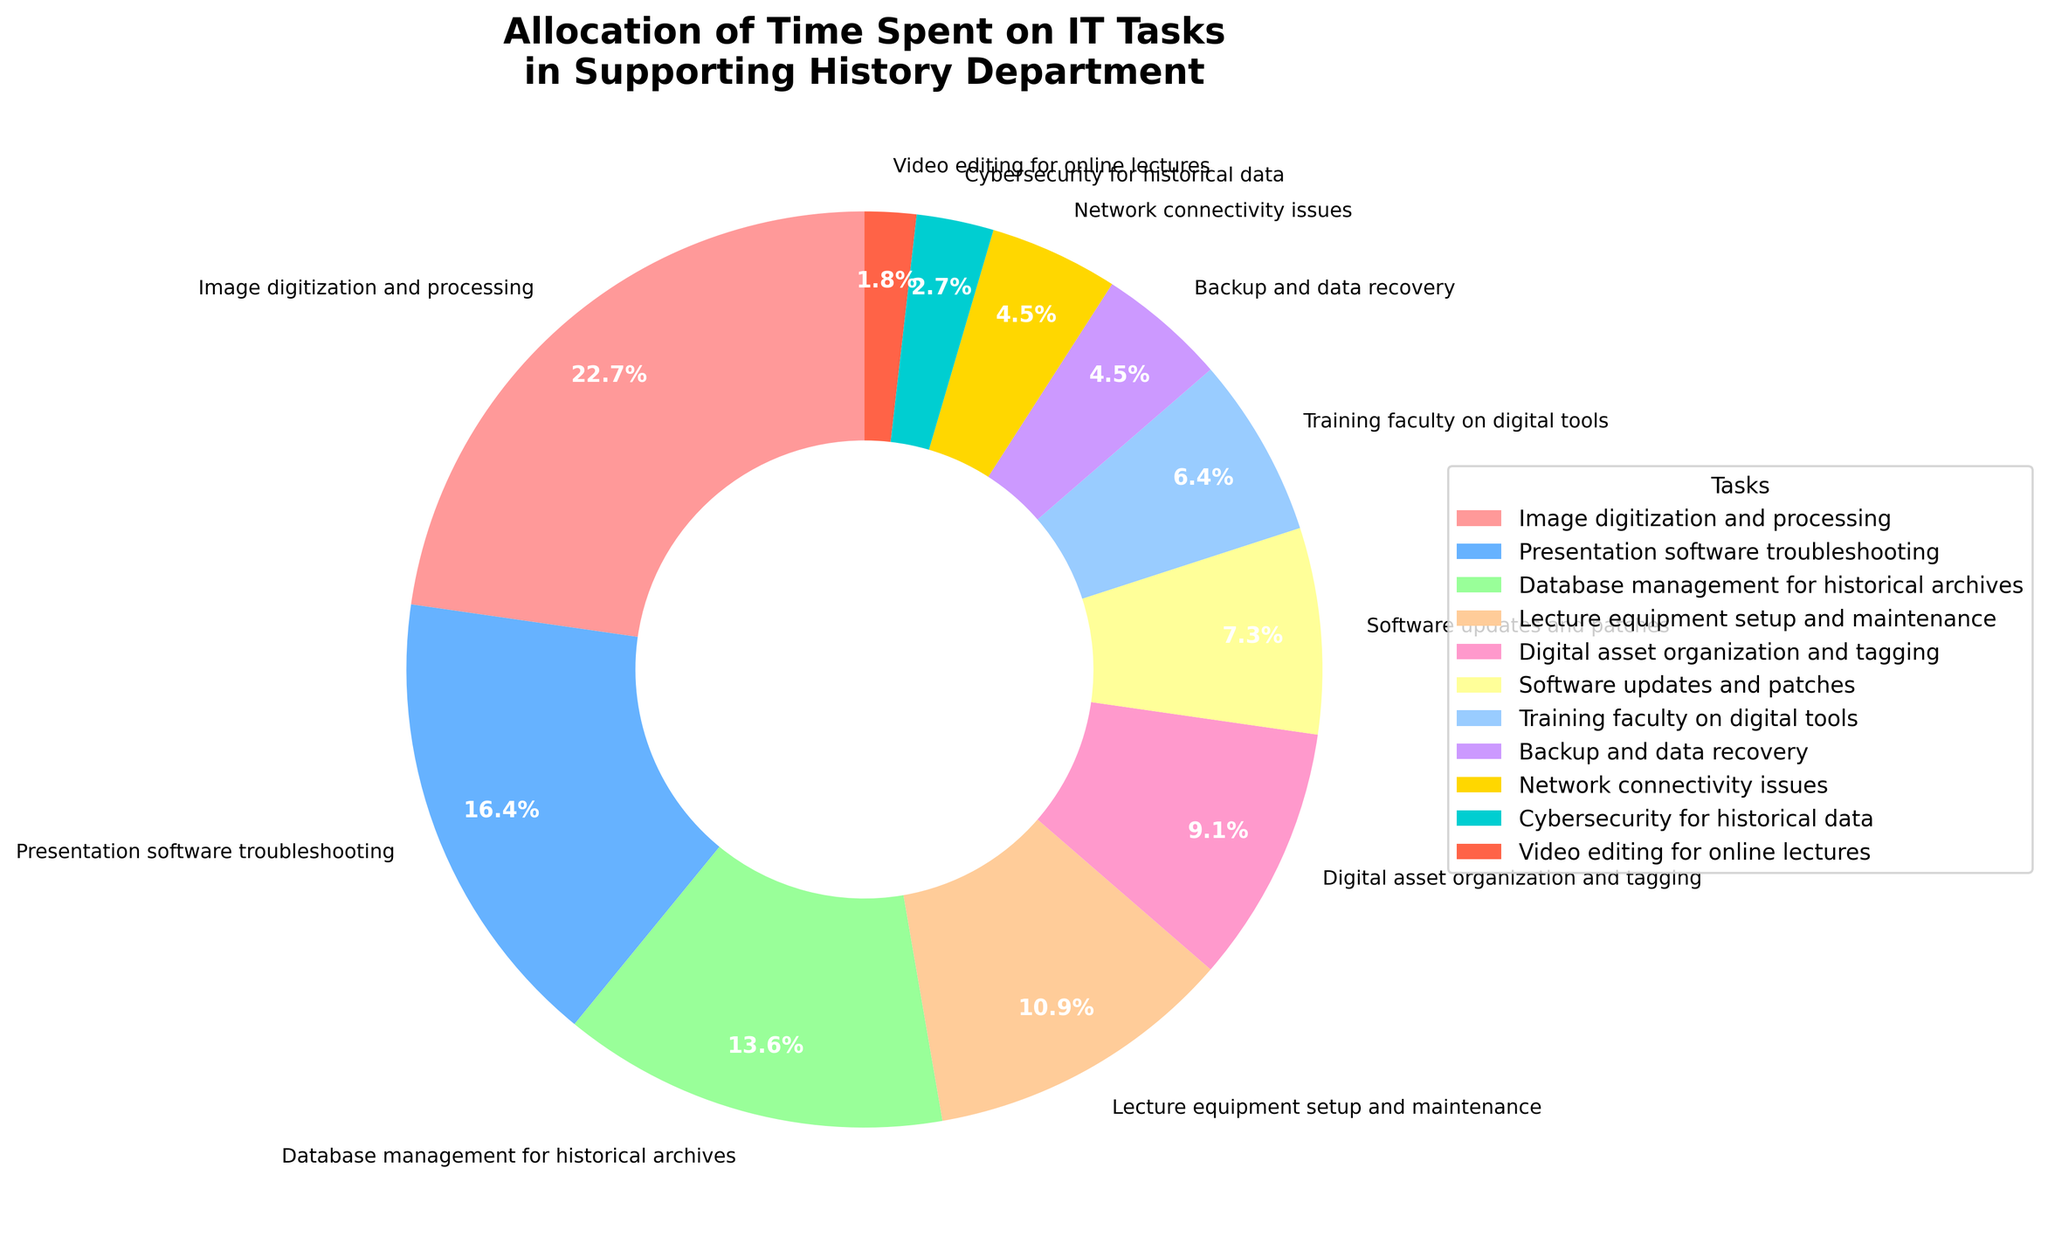What task occupies the largest percentage of time? Identify the task with the highest percentage slice in the pie chart. The largest slice corresponds to "Image digitization and processing" at 25%.
Answer: Image digitization and processing Which task is allocated the least amount of time? Look for the smallest segment in the pie chart. The smallest slice belongs to "Video editing for online lectures" at 2%.
Answer: Video editing for online lectures What is the combined percentage of time spent on Presentation software troubleshooting and Database management for historical archives? Sum the percentages for "Presentation software troubleshooting" (18%) and "Database management for historical archives" (15%). 18% + 15% = 33%.
Answer: 33% How does the percentage of time spent on Lecture equipment setup and maintenance compare to Digital asset organization and tagging? Compare the two percentages: Lecture equipment setup and maintenance is 12%, whereas Digital asset organization and tagging is 10%. 12% is greater than 10%.
Answer: Lecture equipment setup and maintenance is greater What is the difference in time allocation between Training faculty on digital tools and Image digitization and processing? Subtract the percentage for Training faculty on digital tools (7%) from Image digitization and processing (25%). 25% - 7% = 18%.
Answer: 18% What is the total percentage of time allotted to tasks directly involving data (Database management, Backup and data recovery, Cybersecurity)? Sum the percentages of "Database management for historical archives" (15%), "Backup and data recovery" (5%), and "Cybersecurity for historical data" (3%). 15% + 5% + 3% = 23%.
Answer: 23% Which tasks have a percentage allocation of less than 10%? Identify the tasks with less than 10% allocation: "Software updates and patches" (8%), "Training faculty on digital tools" (7%), "Backup and data recovery" (5%), "Network connectivity issues" (5%), "Cybersecurity for historical data" (3%), and "Video editing for online lectures" (2%).
Answer: Software updates and patches, Training faculty on digital tools, Backup and data recovery, Network connectivity issues, Cybersecurity for historical data, Video editing for online lectures How does the time allocation for Network connectivity issues compare to Software updates and patches? Compare the two percentages: Network connectivity issues is 5%, and Software updates and patches is 8%. 5% is less than 8%.
Answer: Network connectivity issues is less What's the average percentage of time spent on Digital asset organization and tagging, Backup and data recovery, and Network connectivity issues? Sum the percentages and divide by the number of tasks. (10% + 5% + 5%) / 3 = 20% / 3 ≈ 6.67%.
Answer: Approximately 6.67% 